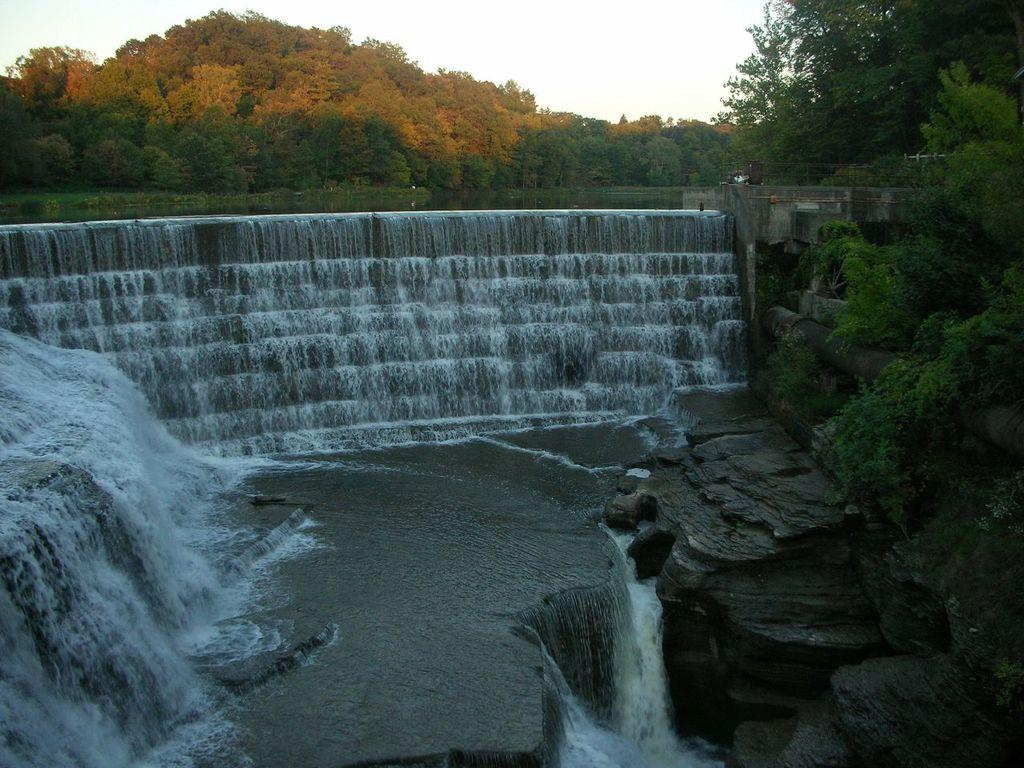What type of natural features can be seen in the image? There are rocks, plants, trees, and a waterfall in the image. What else can be seen in the background of the image? The sky is visible in the background of the image. What type of tub is visible in the image? There is no tub present in the image. What list or sorting method is being used in the image? There is no list or sorting method present in the image. 